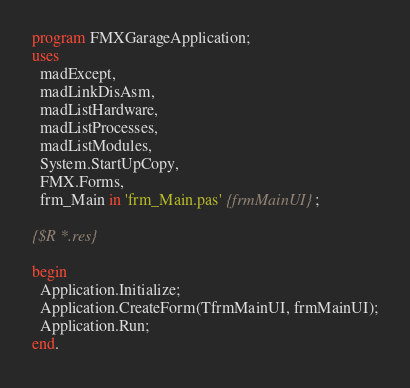Convert code to text. <code><loc_0><loc_0><loc_500><loc_500><_Pascal_>program FMXGarageApplication;
uses
  madExcept,
  madLinkDisAsm,
  madListHardware,
  madListProcesses,
  madListModules,
  System.StartUpCopy,
  FMX.Forms,
  frm_Main in 'frm_Main.pas' {frmMainUI};

{$R *.res}

begin
  Application.Initialize;
  Application.CreateForm(TfrmMainUI, frmMainUI);
  Application.Run;
end.
</code> 